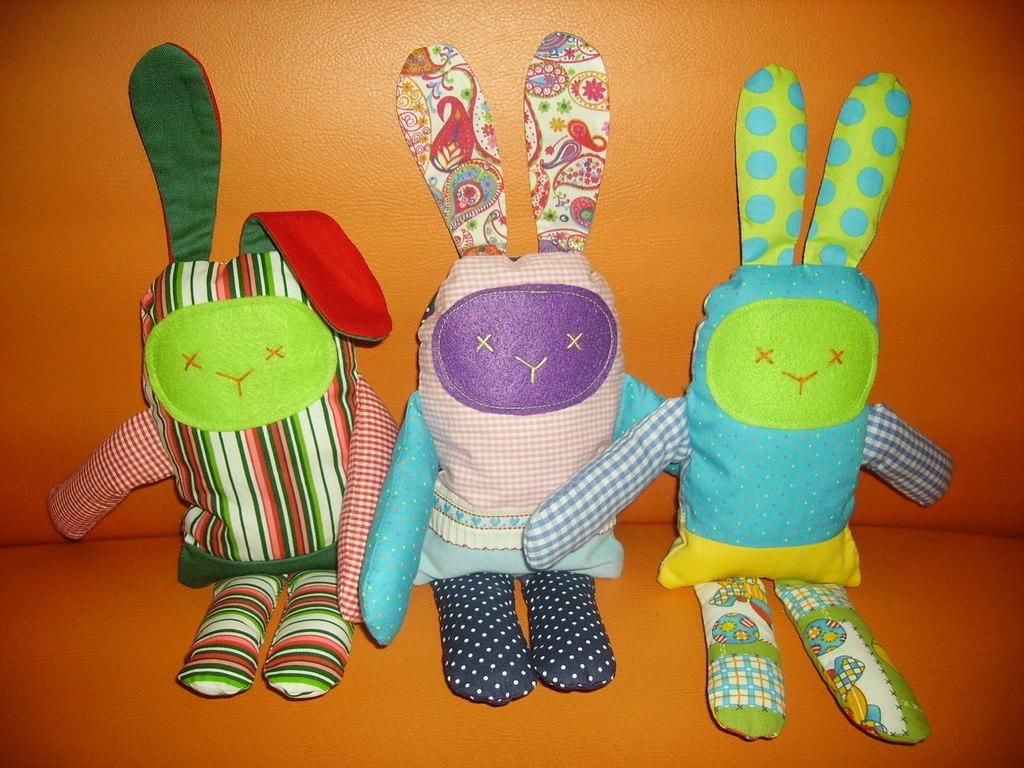How many toys are present in the image? There are three toys in the image. Where are the toys located in the image? The toys are in the middle of the image. What color is the background of the image? The background of the image is in orange color. What arithmetic problem is being solved by the toys in the image? There is no arithmetic problem being solved by the toys in the image, as they are inanimate objects and cannot perform mathematical calculations. 